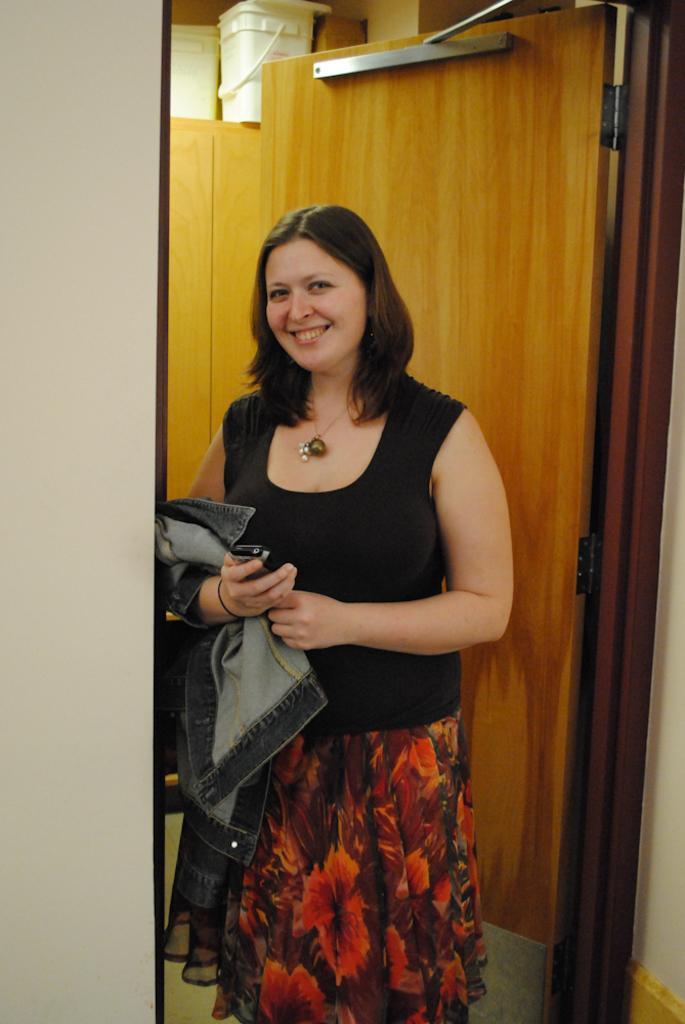How would you summarize this image in a sentence or two? In the center of the image we can see a lady standing and smiling. She is holding a mobile and a jacket. In the background there is a wall and we can see a door. There are brackets placed in the shelf. 